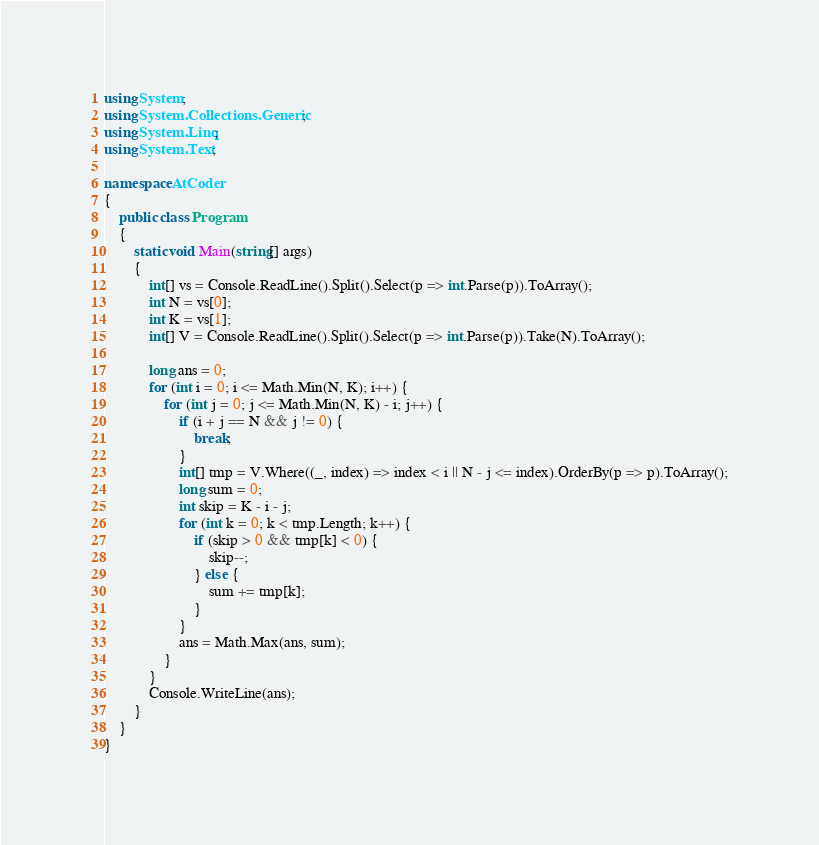<code> <loc_0><loc_0><loc_500><loc_500><_C#_>using System;
using System.Collections.Generic;
using System.Linq;
using System.Text;

namespace AtCoder
{
	public class Program
	{
		static void Main(string[] args)
		{
			int[] vs = Console.ReadLine().Split().Select(p => int.Parse(p)).ToArray();
			int N = vs[0];
			int K = vs[1];
			int[] V = Console.ReadLine().Split().Select(p => int.Parse(p)).Take(N).ToArray();

			long ans = 0;
			for (int i = 0; i <= Math.Min(N, K); i++) {
				for (int j = 0; j <= Math.Min(N, K) - i; j++) {
					if (i + j == N && j != 0) {
						break;
					}
					int[] tmp = V.Where((_, index) => index < i || N - j <= index).OrderBy(p => p).ToArray();
					long sum = 0;
					int skip = K - i - j;
					for (int k = 0; k < tmp.Length; k++) {
						if (skip > 0 && tmp[k] < 0) {
							skip--;
						} else {
							sum += tmp[k];
						}
					}
					ans = Math.Max(ans, sum);
				}
			}
			Console.WriteLine(ans);
		}
	}
}
</code> 